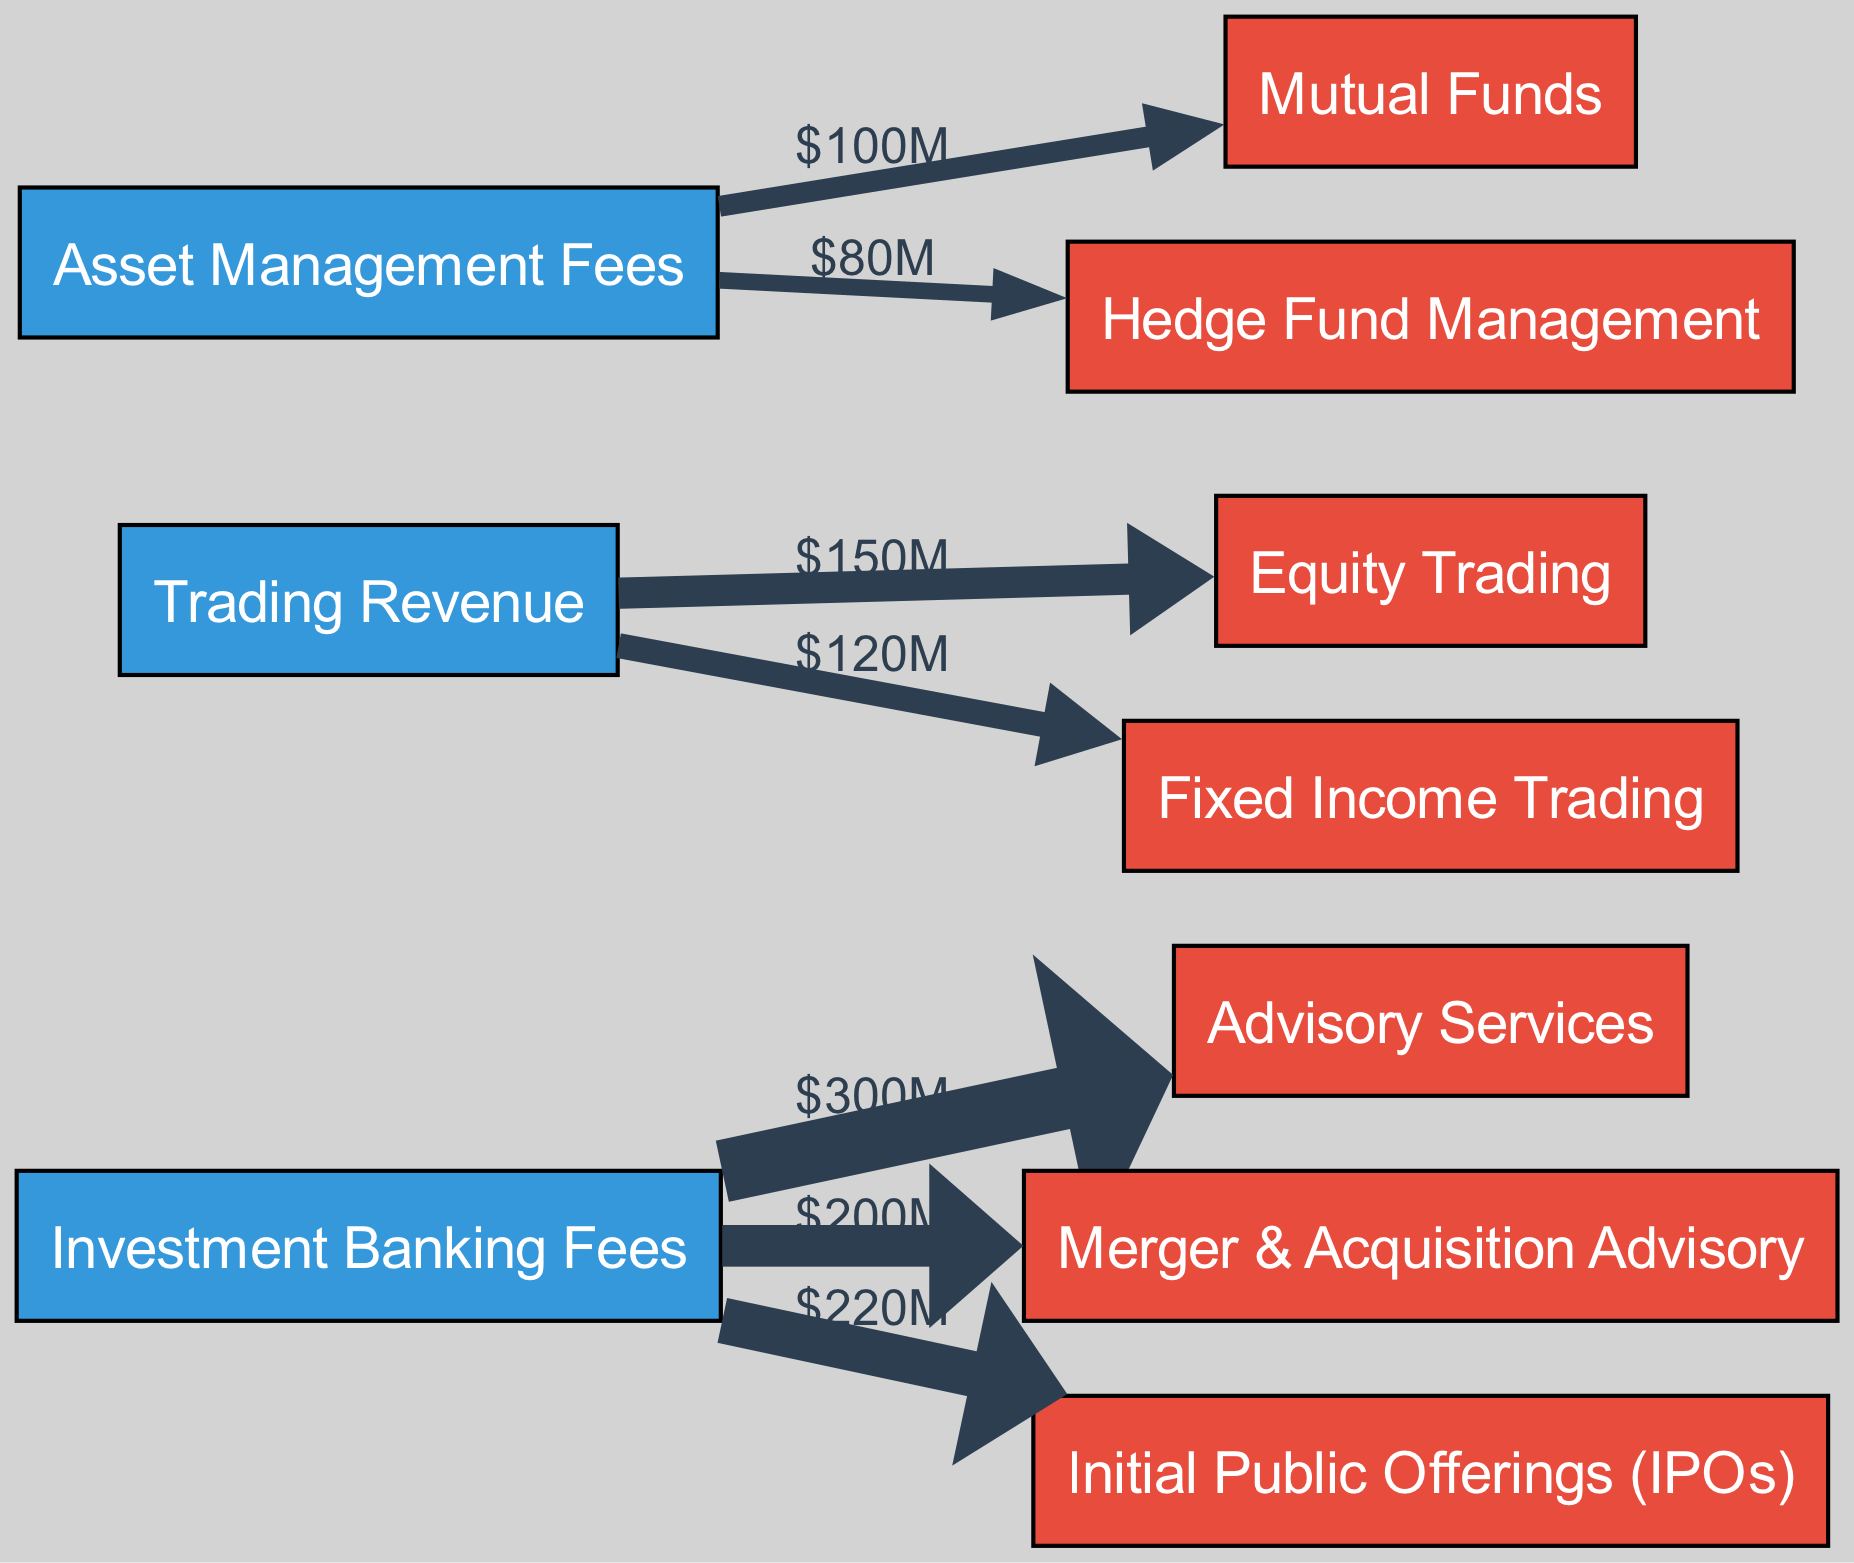What is the total revenue generated from Investment Banking Fees in Q3 2023? The total revenue from Investment Banking Fees is calculated by summing all links from this source node. The values associated with Advisory Services ($300M), Merger & Acquisition Advisory ($200M), and Initial Public Offerings ($220M) add up to $720M.
Answer: 720 million Which service earned the highest revenue from Asset Management Fees? To find the service with the highest revenue from Asset Management Fees, we look at the links originating from this source. The values are $100M for Mutual Funds and $80M for Hedge Fund Management; therefore, Mutual Funds generated the highest revenue.
Answer: Mutual Funds How much revenue was generated from Fixed Income Trading? The revenue generated from Fixed Income Trading is directly indicated on the link from Trading Revenue to Fixed Income Trading, which shows a value of $120M.
Answer: 120 million What is the relationship between Investment Banking Fees and Merger & Acquisition Advisory? The relationship is indicated by a link between Investment Banking Fees (source) and Merger & Acquisition Advisory (target), with a derived revenue of $200M, showing that Investment Banking Fees contribute to the revenue of Merger & Acquisition Advisory.
Answer: 200 million Which source generated revenue for the least number of services? By analyzing the sources, Investment Banking Fees connects to three services (Advisory Services, Merger & Acquisition Advisory, and Initial Public Offerings), Trading Revenue connects to two (Equity Trading and Fixed Income Trading), and Asset Management Fees connects to two services (Mutual Funds and Hedge Fund Management). Therefore, Trading Revenue and Asset Management Fees both generated revenue for the least number of services, which is two.
Answer: Two services What is the total revenue generated from all sources combined? To find the total revenue generated from all sources, we sum the values from each link: Investment Banking Fees ($300M + $200M + $220M = $720M), Trading Revenue ($150M + $120M = $270M), and Asset Management Fees ($100M + $80M = $180M). Adding these gives a total of $1170M.
Answer: 1170 million How many total links are present in the diagram? The total number of links is determined by counting the direct connections between sources and services shown in the diagram. There are six links listed: three from Investment Banking Fees, two from Trading Revenue, and two from Asset Management Fees, totaling six links.
Answer: Six Which services receive revenue from the Trading Revenue source? The services receiving revenue from the Trading Revenue source can be identified by checking the links from Trading Revenue. These services are Equity Trading, associated with $150M, and Fixed Income Trading, associated with $120M. Thus, both services receive revenue.
Answer: Equity Trading and Fixed Income Trading 